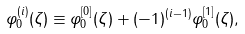<formula> <loc_0><loc_0><loc_500><loc_500>\varphi _ { 0 } ^ { ( i ) } ( \zeta ) \equiv \varphi ^ { [ 0 ] } _ { 0 } ( \zeta ) + ( - 1 ) ^ { ( i - 1 ) } \varphi ^ { [ 1 ] } _ { 0 } ( \zeta ) ,</formula> 